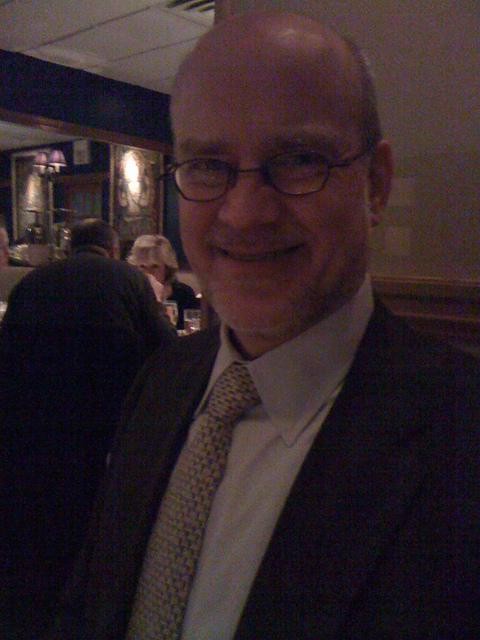What venue is the man in?

Choices:
A) home
B) restaurant
C) bathroom
D) hotel lobby restaurant 